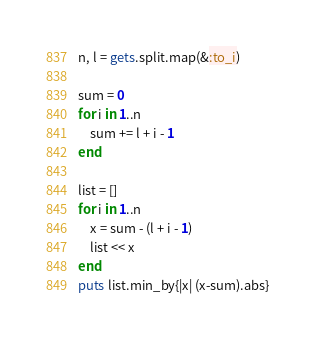<code> <loc_0><loc_0><loc_500><loc_500><_Ruby_>n, l = gets.split.map(&:to_i)

sum = 0
for i in 1..n
	sum += l + i - 1
end

list = []
for i in 1..n
	x = sum - (l + i - 1)
	list << x
end
puts list.min_by{|x| (x-sum).abs}
</code> 